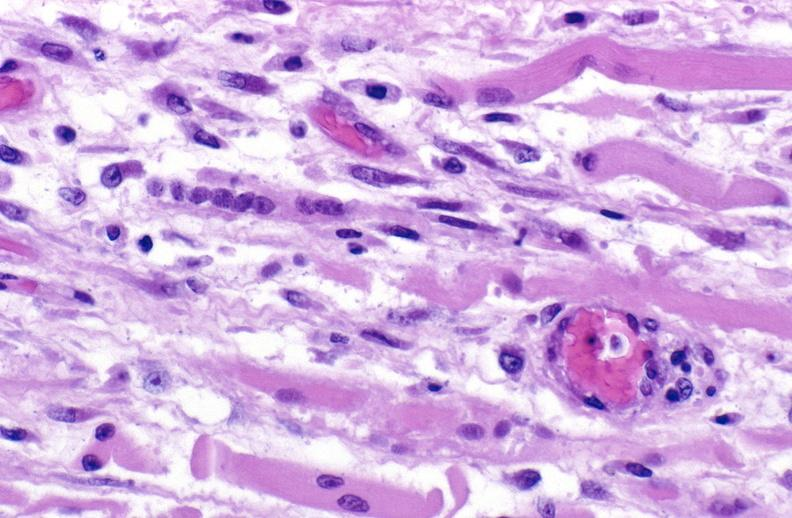s muscle present?
Answer the question using a single word or phrase. Yes 